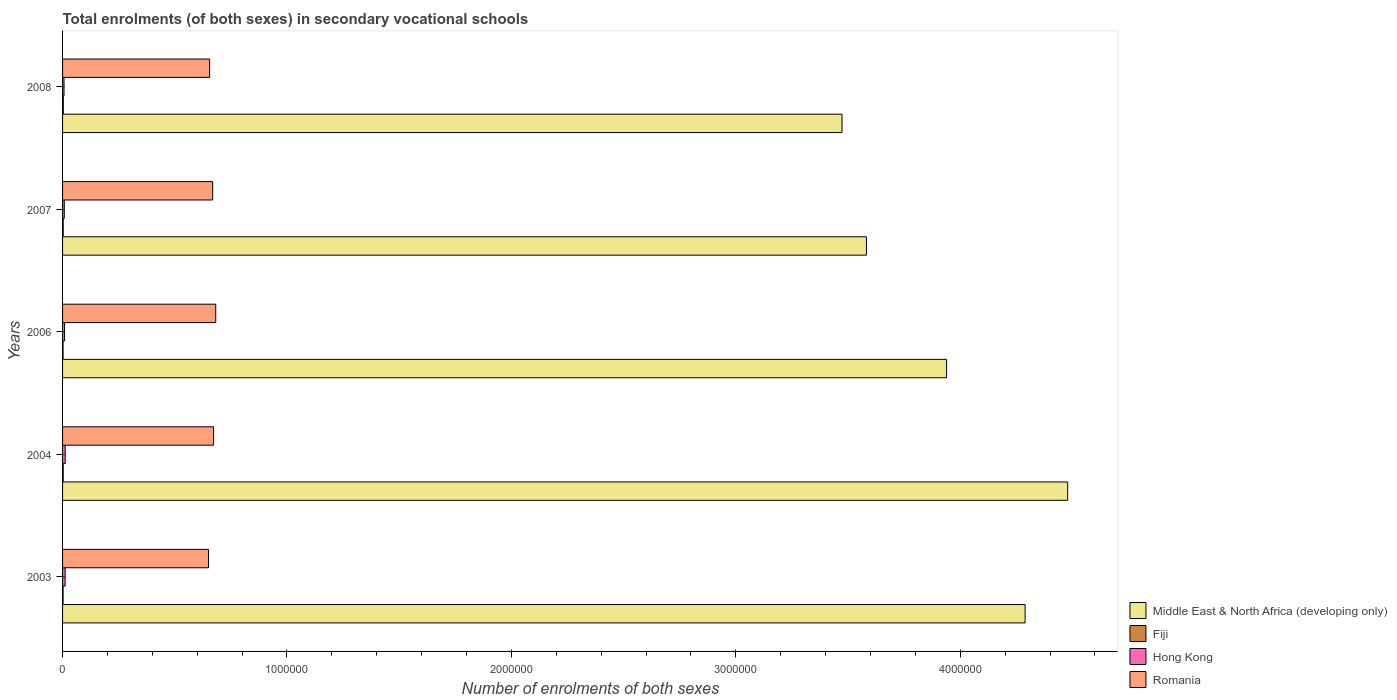How many groups of bars are there?
Ensure brevity in your answer.  5. Are the number of bars per tick equal to the number of legend labels?
Your response must be concise. Yes. How many bars are there on the 2nd tick from the top?
Give a very brief answer. 4. How many bars are there on the 5th tick from the bottom?
Offer a terse response. 4. What is the label of the 4th group of bars from the top?
Provide a succinct answer. 2004. What is the number of enrolments in secondary schools in Romania in 2003?
Keep it short and to the point. 6.50e+05. Across all years, what is the maximum number of enrolments in secondary schools in Fiji?
Offer a terse response. 3351. Across all years, what is the minimum number of enrolments in secondary schools in Hong Kong?
Ensure brevity in your answer.  6430. What is the total number of enrolments in secondary schools in Hong Kong in the graph?
Give a very brief answer. 4.62e+04. What is the difference between the number of enrolments in secondary schools in Fiji in 2004 and that in 2008?
Make the answer very short. -511. What is the difference between the number of enrolments in secondary schools in Middle East & North Africa (developing only) in 2004 and the number of enrolments in secondary schools in Romania in 2003?
Give a very brief answer. 3.83e+06. What is the average number of enrolments in secondary schools in Romania per year?
Provide a succinct answer. 6.66e+05. In the year 2008, what is the difference between the number of enrolments in secondary schools in Middle East & North Africa (developing only) and number of enrolments in secondary schools in Romania?
Your answer should be compact. 2.82e+06. What is the ratio of the number of enrolments in secondary schools in Fiji in 2004 to that in 2006?
Your response must be concise. 1.28. Is the number of enrolments in secondary schools in Middle East & North Africa (developing only) in 2003 less than that in 2004?
Give a very brief answer. Yes. Is the difference between the number of enrolments in secondary schools in Middle East & North Africa (developing only) in 2003 and 2007 greater than the difference between the number of enrolments in secondary schools in Romania in 2003 and 2007?
Offer a very short reply. Yes. What is the difference between the highest and the second highest number of enrolments in secondary schools in Fiji?
Your answer should be compact. 488. What is the difference between the highest and the lowest number of enrolments in secondary schools in Fiji?
Your response must be concise. 1125. In how many years, is the number of enrolments in secondary schools in Middle East & North Africa (developing only) greater than the average number of enrolments in secondary schools in Middle East & North Africa (developing only) taken over all years?
Offer a very short reply. 2. What does the 1st bar from the top in 2008 represents?
Offer a very short reply. Romania. What does the 1st bar from the bottom in 2004 represents?
Your answer should be very brief. Middle East & North Africa (developing only). Is it the case that in every year, the sum of the number of enrolments in secondary schools in Romania and number of enrolments in secondary schools in Hong Kong is greater than the number of enrolments in secondary schools in Middle East & North Africa (developing only)?
Your response must be concise. No. How many bars are there?
Keep it short and to the point. 20. Are all the bars in the graph horizontal?
Provide a short and direct response. Yes. What is the difference between two consecutive major ticks on the X-axis?
Ensure brevity in your answer.  1.00e+06. Does the graph contain any zero values?
Your response must be concise. No. Does the graph contain grids?
Give a very brief answer. No. Where does the legend appear in the graph?
Your response must be concise. Bottom right. How many legend labels are there?
Give a very brief answer. 4. How are the legend labels stacked?
Ensure brevity in your answer.  Vertical. What is the title of the graph?
Your answer should be compact. Total enrolments (of both sexes) in secondary vocational schools. What is the label or title of the X-axis?
Keep it short and to the point. Number of enrolments of both sexes. What is the Number of enrolments of both sexes in Middle East & North Africa (developing only) in 2003?
Your response must be concise. 4.29e+06. What is the Number of enrolments of both sexes of Fiji in 2003?
Ensure brevity in your answer.  2319. What is the Number of enrolments of both sexes of Hong Kong in 2003?
Ensure brevity in your answer.  1.15e+04. What is the Number of enrolments of both sexes in Romania in 2003?
Your answer should be compact. 6.50e+05. What is the Number of enrolments of both sexes in Middle East & North Africa (developing only) in 2004?
Your response must be concise. 4.48e+06. What is the Number of enrolments of both sexes in Fiji in 2004?
Your answer should be compact. 2840. What is the Number of enrolments of both sexes of Hong Kong in 2004?
Your response must be concise. 1.17e+04. What is the Number of enrolments of both sexes in Romania in 2004?
Ensure brevity in your answer.  6.73e+05. What is the Number of enrolments of both sexes in Middle East & North Africa (developing only) in 2006?
Provide a short and direct response. 3.94e+06. What is the Number of enrolments of both sexes of Fiji in 2006?
Keep it short and to the point. 2226. What is the Number of enrolments of both sexes of Hong Kong in 2006?
Offer a terse response. 8807. What is the Number of enrolments of both sexes in Romania in 2006?
Keep it short and to the point. 6.83e+05. What is the Number of enrolments of both sexes in Middle East & North Africa (developing only) in 2007?
Your response must be concise. 3.58e+06. What is the Number of enrolments of both sexes of Fiji in 2007?
Offer a very short reply. 2863. What is the Number of enrolments of both sexes of Hong Kong in 2007?
Give a very brief answer. 7674. What is the Number of enrolments of both sexes of Romania in 2007?
Your response must be concise. 6.69e+05. What is the Number of enrolments of both sexes of Middle East & North Africa (developing only) in 2008?
Offer a very short reply. 3.47e+06. What is the Number of enrolments of both sexes of Fiji in 2008?
Your response must be concise. 3351. What is the Number of enrolments of both sexes of Hong Kong in 2008?
Your response must be concise. 6430. What is the Number of enrolments of both sexes of Romania in 2008?
Provide a short and direct response. 6.55e+05. Across all years, what is the maximum Number of enrolments of both sexes of Middle East & North Africa (developing only)?
Your answer should be compact. 4.48e+06. Across all years, what is the maximum Number of enrolments of both sexes of Fiji?
Provide a succinct answer. 3351. Across all years, what is the maximum Number of enrolments of both sexes in Hong Kong?
Your answer should be very brief. 1.17e+04. Across all years, what is the maximum Number of enrolments of both sexes of Romania?
Keep it short and to the point. 6.83e+05. Across all years, what is the minimum Number of enrolments of both sexes of Middle East & North Africa (developing only)?
Ensure brevity in your answer.  3.47e+06. Across all years, what is the minimum Number of enrolments of both sexes of Fiji?
Keep it short and to the point. 2226. Across all years, what is the minimum Number of enrolments of both sexes in Hong Kong?
Keep it short and to the point. 6430. Across all years, what is the minimum Number of enrolments of both sexes in Romania?
Ensure brevity in your answer.  6.50e+05. What is the total Number of enrolments of both sexes in Middle East & North Africa (developing only) in the graph?
Ensure brevity in your answer.  1.98e+07. What is the total Number of enrolments of both sexes of Fiji in the graph?
Your answer should be very brief. 1.36e+04. What is the total Number of enrolments of both sexes of Hong Kong in the graph?
Keep it short and to the point. 4.62e+04. What is the total Number of enrolments of both sexes in Romania in the graph?
Keep it short and to the point. 3.33e+06. What is the difference between the Number of enrolments of both sexes of Middle East & North Africa (developing only) in 2003 and that in 2004?
Ensure brevity in your answer.  -1.90e+05. What is the difference between the Number of enrolments of both sexes of Fiji in 2003 and that in 2004?
Your response must be concise. -521. What is the difference between the Number of enrolments of both sexes in Hong Kong in 2003 and that in 2004?
Ensure brevity in your answer.  -185. What is the difference between the Number of enrolments of both sexes of Romania in 2003 and that in 2004?
Make the answer very short. -2.22e+04. What is the difference between the Number of enrolments of both sexes of Middle East & North Africa (developing only) in 2003 and that in 2006?
Offer a terse response. 3.50e+05. What is the difference between the Number of enrolments of both sexes of Fiji in 2003 and that in 2006?
Your answer should be compact. 93. What is the difference between the Number of enrolments of both sexes in Hong Kong in 2003 and that in 2006?
Your response must be concise. 2738. What is the difference between the Number of enrolments of both sexes in Romania in 2003 and that in 2006?
Make the answer very short. -3.20e+04. What is the difference between the Number of enrolments of both sexes in Middle East & North Africa (developing only) in 2003 and that in 2007?
Provide a succinct answer. 7.07e+05. What is the difference between the Number of enrolments of both sexes of Fiji in 2003 and that in 2007?
Provide a short and direct response. -544. What is the difference between the Number of enrolments of both sexes of Hong Kong in 2003 and that in 2007?
Ensure brevity in your answer.  3871. What is the difference between the Number of enrolments of both sexes of Romania in 2003 and that in 2007?
Provide a succinct answer. -1.84e+04. What is the difference between the Number of enrolments of both sexes in Middle East & North Africa (developing only) in 2003 and that in 2008?
Provide a short and direct response. 8.16e+05. What is the difference between the Number of enrolments of both sexes in Fiji in 2003 and that in 2008?
Your answer should be very brief. -1032. What is the difference between the Number of enrolments of both sexes of Hong Kong in 2003 and that in 2008?
Keep it short and to the point. 5115. What is the difference between the Number of enrolments of both sexes of Romania in 2003 and that in 2008?
Make the answer very short. -4789. What is the difference between the Number of enrolments of both sexes in Middle East & North Africa (developing only) in 2004 and that in 2006?
Give a very brief answer. 5.40e+05. What is the difference between the Number of enrolments of both sexes of Fiji in 2004 and that in 2006?
Your response must be concise. 614. What is the difference between the Number of enrolments of both sexes in Hong Kong in 2004 and that in 2006?
Provide a succinct answer. 2923. What is the difference between the Number of enrolments of both sexes in Romania in 2004 and that in 2006?
Offer a very short reply. -9824. What is the difference between the Number of enrolments of both sexes of Middle East & North Africa (developing only) in 2004 and that in 2007?
Provide a succinct answer. 8.97e+05. What is the difference between the Number of enrolments of both sexes of Fiji in 2004 and that in 2007?
Your response must be concise. -23. What is the difference between the Number of enrolments of both sexes in Hong Kong in 2004 and that in 2007?
Your answer should be compact. 4056. What is the difference between the Number of enrolments of both sexes of Romania in 2004 and that in 2007?
Provide a short and direct response. 3808. What is the difference between the Number of enrolments of both sexes in Middle East & North Africa (developing only) in 2004 and that in 2008?
Offer a terse response. 1.01e+06. What is the difference between the Number of enrolments of both sexes in Fiji in 2004 and that in 2008?
Give a very brief answer. -511. What is the difference between the Number of enrolments of both sexes in Hong Kong in 2004 and that in 2008?
Your answer should be very brief. 5300. What is the difference between the Number of enrolments of both sexes in Romania in 2004 and that in 2008?
Provide a short and direct response. 1.74e+04. What is the difference between the Number of enrolments of both sexes of Middle East & North Africa (developing only) in 2006 and that in 2007?
Provide a succinct answer. 3.57e+05. What is the difference between the Number of enrolments of both sexes of Fiji in 2006 and that in 2007?
Your response must be concise. -637. What is the difference between the Number of enrolments of both sexes of Hong Kong in 2006 and that in 2007?
Make the answer very short. 1133. What is the difference between the Number of enrolments of both sexes in Romania in 2006 and that in 2007?
Ensure brevity in your answer.  1.36e+04. What is the difference between the Number of enrolments of both sexes of Middle East & North Africa (developing only) in 2006 and that in 2008?
Make the answer very short. 4.66e+05. What is the difference between the Number of enrolments of both sexes of Fiji in 2006 and that in 2008?
Offer a terse response. -1125. What is the difference between the Number of enrolments of both sexes of Hong Kong in 2006 and that in 2008?
Your response must be concise. 2377. What is the difference between the Number of enrolments of both sexes of Romania in 2006 and that in 2008?
Offer a very short reply. 2.73e+04. What is the difference between the Number of enrolments of both sexes in Middle East & North Africa (developing only) in 2007 and that in 2008?
Your response must be concise. 1.09e+05. What is the difference between the Number of enrolments of both sexes of Fiji in 2007 and that in 2008?
Offer a very short reply. -488. What is the difference between the Number of enrolments of both sexes in Hong Kong in 2007 and that in 2008?
Offer a terse response. 1244. What is the difference between the Number of enrolments of both sexes in Romania in 2007 and that in 2008?
Your answer should be very brief. 1.36e+04. What is the difference between the Number of enrolments of both sexes in Middle East & North Africa (developing only) in 2003 and the Number of enrolments of both sexes in Fiji in 2004?
Offer a very short reply. 4.29e+06. What is the difference between the Number of enrolments of both sexes of Middle East & North Africa (developing only) in 2003 and the Number of enrolments of both sexes of Hong Kong in 2004?
Give a very brief answer. 4.28e+06. What is the difference between the Number of enrolments of both sexes of Middle East & North Africa (developing only) in 2003 and the Number of enrolments of both sexes of Romania in 2004?
Provide a succinct answer. 3.62e+06. What is the difference between the Number of enrolments of both sexes of Fiji in 2003 and the Number of enrolments of both sexes of Hong Kong in 2004?
Provide a short and direct response. -9411. What is the difference between the Number of enrolments of both sexes in Fiji in 2003 and the Number of enrolments of both sexes in Romania in 2004?
Make the answer very short. -6.70e+05. What is the difference between the Number of enrolments of both sexes in Hong Kong in 2003 and the Number of enrolments of both sexes in Romania in 2004?
Your response must be concise. -6.61e+05. What is the difference between the Number of enrolments of both sexes in Middle East & North Africa (developing only) in 2003 and the Number of enrolments of both sexes in Fiji in 2006?
Offer a terse response. 4.29e+06. What is the difference between the Number of enrolments of both sexes of Middle East & North Africa (developing only) in 2003 and the Number of enrolments of both sexes of Hong Kong in 2006?
Make the answer very short. 4.28e+06. What is the difference between the Number of enrolments of both sexes of Middle East & North Africa (developing only) in 2003 and the Number of enrolments of both sexes of Romania in 2006?
Give a very brief answer. 3.61e+06. What is the difference between the Number of enrolments of both sexes in Fiji in 2003 and the Number of enrolments of both sexes in Hong Kong in 2006?
Your answer should be very brief. -6488. What is the difference between the Number of enrolments of both sexes in Fiji in 2003 and the Number of enrolments of both sexes in Romania in 2006?
Your answer should be very brief. -6.80e+05. What is the difference between the Number of enrolments of both sexes in Hong Kong in 2003 and the Number of enrolments of both sexes in Romania in 2006?
Offer a terse response. -6.71e+05. What is the difference between the Number of enrolments of both sexes in Middle East & North Africa (developing only) in 2003 and the Number of enrolments of both sexes in Fiji in 2007?
Offer a very short reply. 4.29e+06. What is the difference between the Number of enrolments of both sexes in Middle East & North Africa (developing only) in 2003 and the Number of enrolments of both sexes in Hong Kong in 2007?
Provide a succinct answer. 4.28e+06. What is the difference between the Number of enrolments of both sexes of Middle East & North Africa (developing only) in 2003 and the Number of enrolments of both sexes of Romania in 2007?
Your answer should be compact. 3.62e+06. What is the difference between the Number of enrolments of both sexes of Fiji in 2003 and the Number of enrolments of both sexes of Hong Kong in 2007?
Offer a terse response. -5355. What is the difference between the Number of enrolments of both sexes of Fiji in 2003 and the Number of enrolments of both sexes of Romania in 2007?
Make the answer very short. -6.67e+05. What is the difference between the Number of enrolments of both sexes of Hong Kong in 2003 and the Number of enrolments of both sexes of Romania in 2007?
Your response must be concise. -6.57e+05. What is the difference between the Number of enrolments of both sexes in Middle East & North Africa (developing only) in 2003 and the Number of enrolments of both sexes in Fiji in 2008?
Ensure brevity in your answer.  4.29e+06. What is the difference between the Number of enrolments of both sexes of Middle East & North Africa (developing only) in 2003 and the Number of enrolments of both sexes of Hong Kong in 2008?
Offer a terse response. 4.28e+06. What is the difference between the Number of enrolments of both sexes in Middle East & North Africa (developing only) in 2003 and the Number of enrolments of both sexes in Romania in 2008?
Make the answer very short. 3.63e+06. What is the difference between the Number of enrolments of both sexes in Fiji in 2003 and the Number of enrolments of both sexes in Hong Kong in 2008?
Make the answer very short. -4111. What is the difference between the Number of enrolments of both sexes in Fiji in 2003 and the Number of enrolments of both sexes in Romania in 2008?
Your response must be concise. -6.53e+05. What is the difference between the Number of enrolments of both sexes of Hong Kong in 2003 and the Number of enrolments of both sexes of Romania in 2008?
Keep it short and to the point. -6.44e+05. What is the difference between the Number of enrolments of both sexes of Middle East & North Africa (developing only) in 2004 and the Number of enrolments of both sexes of Fiji in 2006?
Give a very brief answer. 4.48e+06. What is the difference between the Number of enrolments of both sexes in Middle East & North Africa (developing only) in 2004 and the Number of enrolments of both sexes in Hong Kong in 2006?
Offer a very short reply. 4.47e+06. What is the difference between the Number of enrolments of both sexes in Middle East & North Africa (developing only) in 2004 and the Number of enrolments of both sexes in Romania in 2006?
Offer a terse response. 3.80e+06. What is the difference between the Number of enrolments of both sexes in Fiji in 2004 and the Number of enrolments of both sexes in Hong Kong in 2006?
Offer a very short reply. -5967. What is the difference between the Number of enrolments of both sexes of Fiji in 2004 and the Number of enrolments of both sexes of Romania in 2006?
Keep it short and to the point. -6.80e+05. What is the difference between the Number of enrolments of both sexes of Hong Kong in 2004 and the Number of enrolments of both sexes of Romania in 2006?
Offer a very short reply. -6.71e+05. What is the difference between the Number of enrolments of both sexes of Middle East & North Africa (developing only) in 2004 and the Number of enrolments of both sexes of Fiji in 2007?
Give a very brief answer. 4.48e+06. What is the difference between the Number of enrolments of both sexes of Middle East & North Africa (developing only) in 2004 and the Number of enrolments of both sexes of Hong Kong in 2007?
Offer a terse response. 4.47e+06. What is the difference between the Number of enrolments of both sexes in Middle East & North Africa (developing only) in 2004 and the Number of enrolments of both sexes in Romania in 2007?
Keep it short and to the point. 3.81e+06. What is the difference between the Number of enrolments of both sexes in Fiji in 2004 and the Number of enrolments of both sexes in Hong Kong in 2007?
Offer a very short reply. -4834. What is the difference between the Number of enrolments of both sexes of Fiji in 2004 and the Number of enrolments of both sexes of Romania in 2007?
Ensure brevity in your answer.  -6.66e+05. What is the difference between the Number of enrolments of both sexes in Hong Kong in 2004 and the Number of enrolments of both sexes in Romania in 2007?
Your answer should be compact. -6.57e+05. What is the difference between the Number of enrolments of both sexes in Middle East & North Africa (developing only) in 2004 and the Number of enrolments of both sexes in Fiji in 2008?
Make the answer very short. 4.48e+06. What is the difference between the Number of enrolments of both sexes in Middle East & North Africa (developing only) in 2004 and the Number of enrolments of both sexes in Hong Kong in 2008?
Your response must be concise. 4.47e+06. What is the difference between the Number of enrolments of both sexes in Middle East & North Africa (developing only) in 2004 and the Number of enrolments of both sexes in Romania in 2008?
Provide a short and direct response. 3.82e+06. What is the difference between the Number of enrolments of both sexes in Fiji in 2004 and the Number of enrolments of both sexes in Hong Kong in 2008?
Your response must be concise. -3590. What is the difference between the Number of enrolments of both sexes of Fiji in 2004 and the Number of enrolments of both sexes of Romania in 2008?
Offer a very short reply. -6.52e+05. What is the difference between the Number of enrolments of both sexes of Hong Kong in 2004 and the Number of enrolments of both sexes of Romania in 2008?
Ensure brevity in your answer.  -6.44e+05. What is the difference between the Number of enrolments of both sexes of Middle East & North Africa (developing only) in 2006 and the Number of enrolments of both sexes of Fiji in 2007?
Your answer should be compact. 3.94e+06. What is the difference between the Number of enrolments of both sexes in Middle East & North Africa (developing only) in 2006 and the Number of enrolments of both sexes in Hong Kong in 2007?
Your answer should be compact. 3.93e+06. What is the difference between the Number of enrolments of both sexes in Middle East & North Africa (developing only) in 2006 and the Number of enrolments of both sexes in Romania in 2007?
Your answer should be compact. 3.27e+06. What is the difference between the Number of enrolments of both sexes of Fiji in 2006 and the Number of enrolments of both sexes of Hong Kong in 2007?
Your response must be concise. -5448. What is the difference between the Number of enrolments of both sexes in Fiji in 2006 and the Number of enrolments of both sexes in Romania in 2007?
Offer a very short reply. -6.67e+05. What is the difference between the Number of enrolments of both sexes of Hong Kong in 2006 and the Number of enrolments of both sexes of Romania in 2007?
Offer a very short reply. -6.60e+05. What is the difference between the Number of enrolments of both sexes of Middle East & North Africa (developing only) in 2006 and the Number of enrolments of both sexes of Fiji in 2008?
Your response must be concise. 3.94e+06. What is the difference between the Number of enrolments of both sexes of Middle East & North Africa (developing only) in 2006 and the Number of enrolments of both sexes of Hong Kong in 2008?
Offer a terse response. 3.93e+06. What is the difference between the Number of enrolments of both sexes in Middle East & North Africa (developing only) in 2006 and the Number of enrolments of both sexes in Romania in 2008?
Offer a very short reply. 3.28e+06. What is the difference between the Number of enrolments of both sexes in Fiji in 2006 and the Number of enrolments of both sexes in Hong Kong in 2008?
Provide a short and direct response. -4204. What is the difference between the Number of enrolments of both sexes in Fiji in 2006 and the Number of enrolments of both sexes in Romania in 2008?
Provide a short and direct response. -6.53e+05. What is the difference between the Number of enrolments of both sexes of Hong Kong in 2006 and the Number of enrolments of both sexes of Romania in 2008?
Your response must be concise. -6.46e+05. What is the difference between the Number of enrolments of both sexes in Middle East & North Africa (developing only) in 2007 and the Number of enrolments of both sexes in Fiji in 2008?
Ensure brevity in your answer.  3.58e+06. What is the difference between the Number of enrolments of both sexes in Middle East & North Africa (developing only) in 2007 and the Number of enrolments of both sexes in Hong Kong in 2008?
Your response must be concise. 3.58e+06. What is the difference between the Number of enrolments of both sexes in Middle East & North Africa (developing only) in 2007 and the Number of enrolments of both sexes in Romania in 2008?
Ensure brevity in your answer.  2.93e+06. What is the difference between the Number of enrolments of both sexes of Fiji in 2007 and the Number of enrolments of both sexes of Hong Kong in 2008?
Offer a terse response. -3567. What is the difference between the Number of enrolments of both sexes in Fiji in 2007 and the Number of enrolments of both sexes in Romania in 2008?
Offer a very short reply. -6.52e+05. What is the difference between the Number of enrolments of both sexes in Hong Kong in 2007 and the Number of enrolments of both sexes in Romania in 2008?
Keep it short and to the point. -6.48e+05. What is the average Number of enrolments of both sexes in Middle East & North Africa (developing only) per year?
Make the answer very short. 3.95e+06. What is the average Number of enrolments of both sexes in Fiji per year?
Make the answer very short. 2719.8. What is the average Number of enrolments of both sexes in Hong Kong per year?
Keep it short and to the point. 9237.2. What is the average Number of enrolments of both sexes of Romania per year?
Provide a succinct answer. 6.66e+05. In the year 2003, what is the difference between the Number of enrolments of both sexes in Middle East & North Africa (developing only) and Number of enrolments of both sexes in Fiji?
Your answer should be compact. 4.29e+06. In the year 2003, what is the difference between the Number of enrolments of both sexes in Middle East & North Africa (developing only) and Number of enrolments of both sexes in Hong Kong?
Offer a very short reply. 4.28e+06. In the year 2003, what is the difference between the Number of enrolments of both sexes of Middle East & North Africa (developing only) and Number of enrolments of both sexes of Romania?
Your answer should be compact. 3.64e+06. In the year 2003, what is the difference between the Number of enrolments of both sexes of Fiji and Number of enrolments of both sexes of Hong Kong?
Offer a terse response. -9226. In the year 2003, what is the difference between the Number of enrolments of both sexes in Fiji and Number of enrolments of both sexes in Romania?
Offer a very short reply. -6.48e+05. In the year 2003, what is the difference between the Number of enrolments of both sexes in Hong Kong and Number of enrolments of both sexes in Romania?
Give a very brief answer. -6.39e+05. In the year 2004, what is the difference between the Number of enrolments of both sexes in Middle East & North Africa (developing only) and Number of enrolments of both sexes in Fiji?
Your answer should be very brief. 4.48e+06. In the year 2004, what is the difference between the Number of enrolments of both sexes in Middle East & North Africa (developing only) and Number of enrolments of both sexes in Hong Kong?
Ensure brevity in your answer.  4.47e+06. In the year 2004, what is the difference between the Number of enrolments of both sexes in Middle East & North Africa (developing only) and Number of enrolments of both sexes in Romania?
Offer a very short reply. 3.81e+06. In the year 2004, what is the difference between the Number of enrolments of both sexes in Fiji and Number of enrolments of both sexes in Hong Kong?
Your answer should be compact. -8890. In the year 2004, what is the difference between the Number of enrolments of both sexes in Fiji and Number of enrolments of both sexes in Romania?
Provide a short and direct response. -6.70e+05. In the year 2004, what is the difference between the Number of enrolments of both sexes in Hong Kong and Number of enrolments of both sexes in Romania?
Ensure brevity in your answer.  -6.61e+05. In the year 2006, what is the difference between the Number of enrolments of both sexes in Middle East & North Africa (developing only) and Number of enrolments of both sexes in Fiji?
Give a very brief answer. 3.94e+06. In the year 2006, what is the difference between the Number of enrolments of both sexes in Middle East & North Africa (developing only) and Number of enrolments of both sexes in Hong Kong?
Offer a very short reply. 3.93e+06. In the year 2006, what is the difference between the Number of enrolments of both sexes in Middle East & North Africa (developing only) and Number of enrolments of both sexes in Romania?
Offer a terse response. 3.26e+06. In the year 2006, what is the difference between the Number of enrolments of both sexes of Fiji and Number of enrolments of both sexes of Hong Kong?
Keep it short and to the point. -6581. In the year 2006, what is the difference between the Number of enrolments of both sexes of Fiji and Number of enrolments of both sexes of Romania?
Your answer should be very brief. -6.80e+05. In the year 2006, what is the difference between the Number of enrolments of both sexes in Hong Kong and Number of enrolments of both sexes in Romania?
Give a very brief answer. -6.74e+05. In the year 2007, what is the difference between the Number of enrolments of both sexes in Middle East & North Africa (developing only) and Number of enrolments of both sexes in Fiji?
Ensure brevity in your answer.  3.58e+06. In the year 2007, what is the difference between the Number of enrolments of both sexes of Middle East & North Africa (developing only) and Number of enrolments of both sexes of Hong Kong?
Offer a terse response. 3.57e+06. In the year 2007, what is the difference between the Number of enrolments of both sexes of Middle East & North Africa (developing only) and Number of enrolments of both sexes of Romania?
Keep it short and to the point. 2.91e+06. In the year 2007, what is the difference between the Number of enrolments of both sexes in Fiji and Number of enrolments of both sexes in Hong Kong?
Provide a succinct answer. -4811. In the year 2007, what is the difference between the Number of enrolments of both sexes in Fiji and Number of enrolments of both sexes in Romania?
Make the answer very short. -6.66e+05. In the year 2007, what is the difference between the Number of enrolments of both sexes in Hong Kong and Number of enrolments of both sexes in Romania?
Your response must be concise. -6.61e+05. In the year 2008, what is the difference between the Number of enrolments of both sexes of Middle East & North Africa (developing only) and Number of enrolments of both sexes of Fiji?
Your response must be concise. 3.47e+06. In the year 2008, what is the difference between the Number of enrolments of both sexes of Middle East & North Africa (developing only) and Number of enrolments of both sexes of Hong Kong?
Ensure brevity in your answer.  3.47e+06. In the year 2008, what is the difference between the Number of enrolments of both sexes of Middle East & North Africa (developing only) and Number of enrolments of both sexes of Romania?
Give a very brief answer. 2.82e+06. In the year 2008, what is the difference between the Number of enrolments of both sexes in Fiji and Number of enrolments of both sexes in Hong Kong?
Give a very brief answer. -3079. In the year 2008, what is the difference between the Number of enrolments of both sexes of Fiji and Number of enrolments of both sexes of Romania?
Provide a succinct answer. -6.52e+05. In the year 2008, what is the difference between the Number of enrolments of both sexes in Hong Kong and Number of enrolments of both sexes in Romania?
Ensure brevity in your answer.  -6.49e+05. What is the ratio of the Number of enrolments of both sexes in Middle East & North Africa (developing only) in 2003 to that in 2004?
Make the answer very short. 0.96. What is the ratio of the Number of enrolments of both sexes in Fiji in 2003 to that in 2004?
Ensure brevity in your answer.  0.82. What is the ratio of the Number of enrolments of both sexes in Hong Kong in 2003 to that in 2004?
Make the answer very short. 0.98. What is the ratio of the Number of enrolments of both sexes of Middle East & North Africa (developing only) in 2003 to that in 2006?
Your answer should be compact. 1.09. What is the ratio of the Number of enrolments of both sexes in Fiji in 2003 to that in 2006?
Ensure brevity in your answer.  1.04. What is the ratio of the Number of enrolments of both sexes of Hong Kong in 2003 to that in 2006?
Your answer should be compact. 1.31. What is the ratio of the Number of enrolments of both sexes of Romania in 2003 to that in 2006?
Give a very brief answer. 0.95. What is the ratio of the Number of enrolments of both sexes of Middle East & North Africa (developing only) in 2003 to that in 2007?
Your response must be concise. 1.2. What is the ratio of the Number of enrolments of both sexes in Fiji in 2003 to that in 2007?
Provide a succinct answer. 0.81. What is the ratio of the Number of enrolments of both sexes of Hong Kong in 2003 to that in 2007?
Give a very brief answer. 1.5. What is the ratio of the Number of enrolments of both sexes in Romania in 2003 to that in 2007?
Make the answer very short. 0.97. What is the ratio of the Number of enrolments of both sexes of Middle East & North Africa (developing only) in 2003 to that in 2008?
Provide a short and direct response. 1.23. What is the ratio of the Number of enrolments of both sexes of Fiji in 2003 to that in 2008?
Give a very brief answer. 0.69. What is the ratio of the Number of enrolments of both sexes of Hong Kong in 2003 to that in 2008?
Offer a terse response. 1.8. What is the ratio of the Number of enrolments of both sexes of Romania in 2003 to that in 2008?
Provide a succinct answer. 0.99. What is the ratio of the Number of enrolments of both sexes in Middle East & North Africa (developing only) in 2004 to that in 2006?
Provide a short and direct response. 1.14. What is the ratio of the Number of enrolments of both sexes in Fiji in 2004 to that in 2006?
Ensure brevity in your answer.  1.28. What is the ratio of the Number of enrolments of both sexes of Hong Kong in 2004 to that in 2006?
Keep it short and to the point. 1.33. What is the ratio of the Number of enrolments of both sexes in Romania in 2004 to that in 2006?
Provide a short and direct response. 0.99. What is the ratio of the Number of enrolments of both sexes of Middle East & North Africa (developing only) in 2004 to that in 2007?
Your answer should be very brief. 1.25. What is the ratio of the Number of enrolments of both sexes of Fiji in 2004 to that in 2007?
Keep it short and to the point. 0.99. What is the ratio of the Number of enrolments of both sexes of Hong Kong in 2004 to that in 2007?
Ensure brevity in your answer.  1.53. What is the ratio of the Number of enrolments of both sexes in Romania in 2004 to that in 2007?
Offer a terse response. 1.01. What is the ratio of the Number of enrolments of both sexes in Middle East & North Africa (developing only) in 2004 to that in 2008?
Provide a succinct answer. 1.29. What is the ratio of the Number of enrolments of both sexes in Fiji in 2004 to that in 2008?
Make the answer very short. 0.85. What is the ratio of the Number of enrolments of both sexes of Hong Kong in 2004 to that in 2008?
Provide a succinct answer. 1.82. What is the ratio of the Number of enrolments of both sexes of Romania in 2004 to that in 2008?
Provide a short and direct response. 1.03. What is the ratio of the Number of enrolments of both sexes of Middle East & North Africa (developing only) in 2006 to that in 2007?
Your response must be concise. 1.1. What is the ratio of the Number of enrolments of both sexes in Fiji in 2006 to that in 2007?
Offer a terse response. 0.78. What is the ratio of the Number of enrolments of both sexes in Hong Kong in 2006 to that in 2007?
Your answer should be very brief. 1.15. What is the ratio of the Number of enrolments of both sexes in Romania in 2006 to that in 2007?
Your answer should be very brief. 1.02. What is the ratio of the Number of enrolments of both sexes in Middle East & North Africa (developing only) in 2006 to that in 2008?
Your answer should be very brief. 1.13. What is the ratio of the Number of enrolments of both sexes in Fiji in 2006 to that in 2008?
Provide a succinct answer. 0.66. What is the ratio of the Number of enrolments of both sexes in Hong Kong in 2006 to that in 2008?
Offer a very short reply. 1.37. What is the ratio of the Number of enrolments of both sexes of Romania in 2006 to that in 2008?
Give a very brief answer. 1.04. What is the ratio of the Number of enrolments of both sexes of Middle East & North Africa (developing only) in 2007 to that in 2008?
Make the answer very short. 1.03. What is the ratio of the Number of enrolments of both sexes in Fiji in 2007 to that in 2008?
Provide a short and direct response. 0.85. What is the ratio of the Number of enrolments of both sexes of Hong Kong in 2007 to that in 2008?
Provide a short and direct response. 1.19. What is the ratio of the Number of enrolments of both sexes of Romania in 2007 to that in 2008?
Offer a terse response. 1.02. What is the difference between the highest and the second highest Number of enrolments of both sexes of Middle East & North Africa (developing only)?
Your answer should be compact. 1.90e+05. What is the difference between the highest and the second highest Number of enrolments of both sexes of Fiji?
Keep it short and to the point. 488. What is the difference between the highest and the second highest Number of enrolments of both sexes in Hong Kong?
Your answer should be very brief. 185. What is the difference between the highest and the second highest Number of enrolments of both sexes of Romania?
Ensure brevity in your answer.  9824. What is the difference between the highest and the lowest Number of enrolments of both sexes in Middle East & North Africa (developing only)?
Your answer should be compact. 1.01e+06. What is the difference between the highest and the lowest Number of enrolments of both sexes in Fiji?
Your answer should be very brief. 1125. What is the difference between the highest and the lowest Number of enrolments of both sexes of Hong Kong?
Offer a very short reply. 5300. What is the difference between the highest and the lowest Number of enrolments of both sexes of Romania?
Provide a short and direct response. 3.20e+04. 